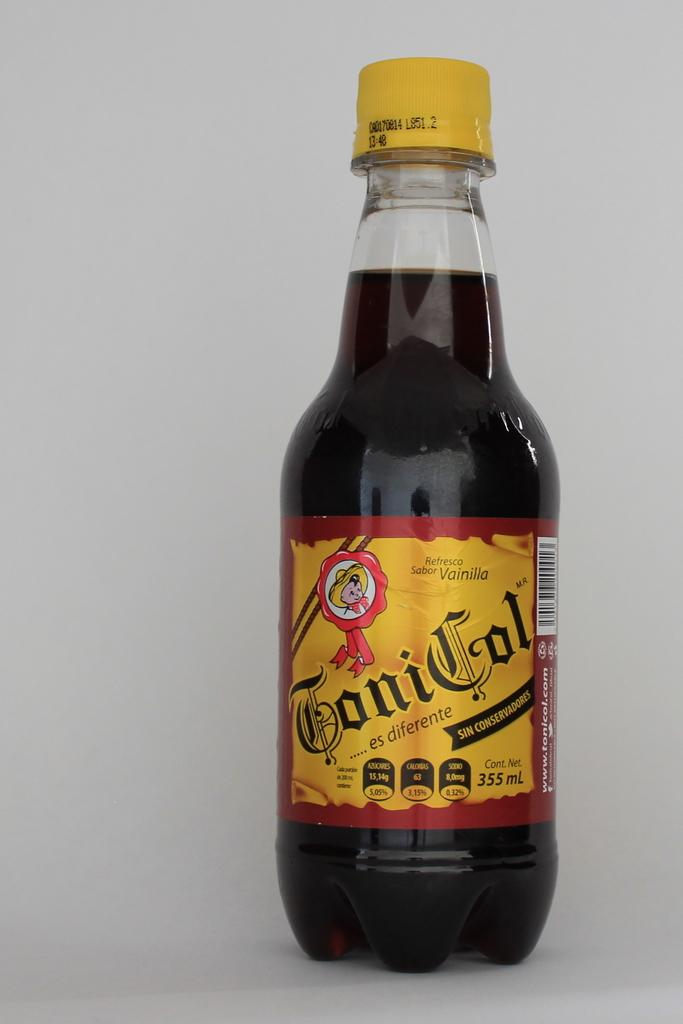What object is present in the image that contains liquid? There is a bottle in the image that is filled with liquid. What can be observed about the lid of the bottle? The lid of the bottle is yellow in color. Where is the bottle located in the image? The bottle is placed on a countertop. Is there a magic spell being cast on the bottle in the image? There is no indication of magic or a spell being cast in the image; it simply shows a bottle with a yellow lid on a countertop. 